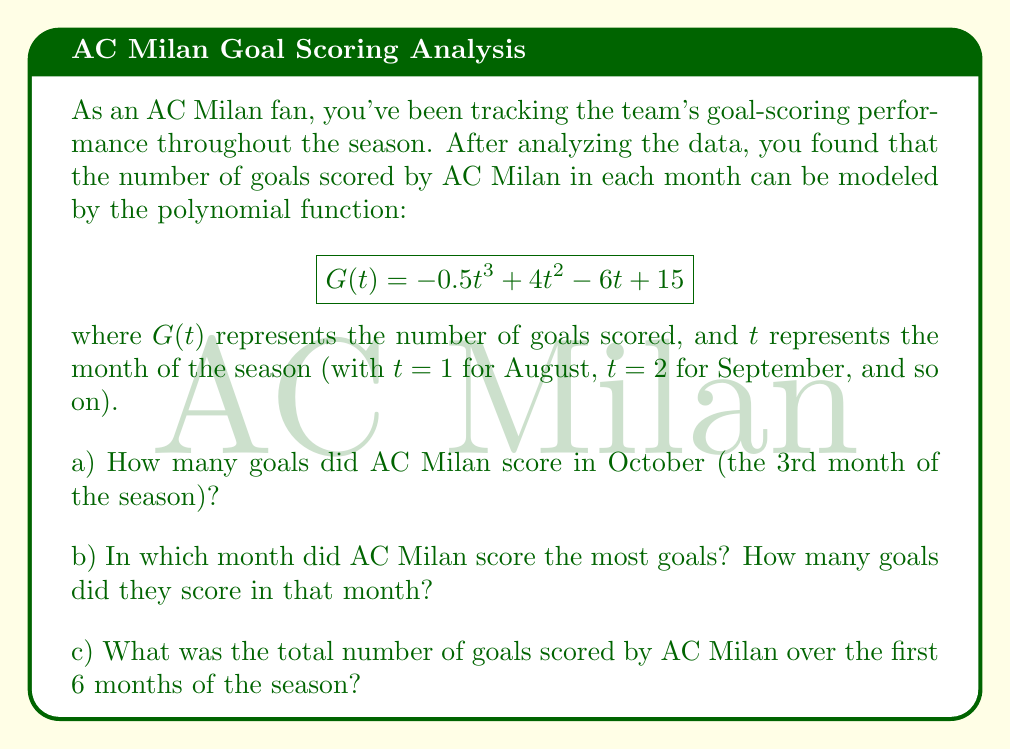What is the answer to this math problem? Let's break this down step by step:

a) To find the number of goals scored in October, we need to calculate $G(3)$ since October is the 3rd month of the season.

$$G(3) = -0.5(3)^3 + 4(3)^2 - 6(3) + 15$$
$$= -0.5(27) + 4(9) - 18 + 15$$
$$= -13.5 + 36 - 18 + 15$$
$$= 19.5$$

Since we can't have a fractional number of goals, we round this to 20 goals.

b) To find the month with the most goals, we need to find the maximum of the function $G(t)$. We can do this by finding where the derivative $G'(t)$ equals zero:

$$G'(t) = -1.5t^2 + 8t - 6$$

Setting this equal to zero:
$$-1.5t^2 + 8t - 6 = 0$$

Solving this quadratic equation:
$$t = \frac{8 \pm \sqrt{64 + 36}}{-3} = \frac{8 \pm 10}{-3}$$

This gives us $t = 6$ or $t = \frac{2}{3}$. Since $t$ represents months, $t = 6$ is our relevant solution.

To confirm this is a maximum, we can check that $G''(6) < 0$:
$$G''(t) = -3t + 8$$
$$G''(6) = -3(6) + 8 = -10 < 0$$

So the maximum occurs when $t = 6$, which corresponds to January.

The number of goals scored in January is:
$$G(6) = -0.5(6)^3 + 4(6)^2 - 6(6) + 15$$
$$= -108 + 144 - 36 + 15$$
$$= 15$$ goals

c) To find the total number of goals over the first 6 months, we need to calculate the definite integral of $G(t)$ from $t=1$ to $t=6$:

$$\int_1^6 G(t) dt = \int_1^6 (-0.5t^3 + 4t^2 - 6t + 15) dt$$

$$= [-0.125t^4 + \frac{4}{3}t^3 - 3t^2 + 15t]_1^6$$

$$= [-0.125(6)^4 + \frac{4}{3}(6)^3 - 3(6)^2 + 15(6)] - [-0.125(1)^4 + \frac{4}{3}(1)^3 - 3(1)^2 + 15(1)]$$

$$= [-135 + 288 - 108 + 90] - [-0.125 + \frac{4}{3} - 3 + 15]$$

$$= 135 - 13.2083$$

$$\approx 121.79$$

Rounding to the nearest whole number, the total number of goals scored over the first 6 months is 122.
Answer: a) AC Milan scored 20 goals in October.
b) AC Milan scored the most goals in January, with 15 goals.
c) AC Milan scored a total of 122 goals over the first 6 months of the season. 